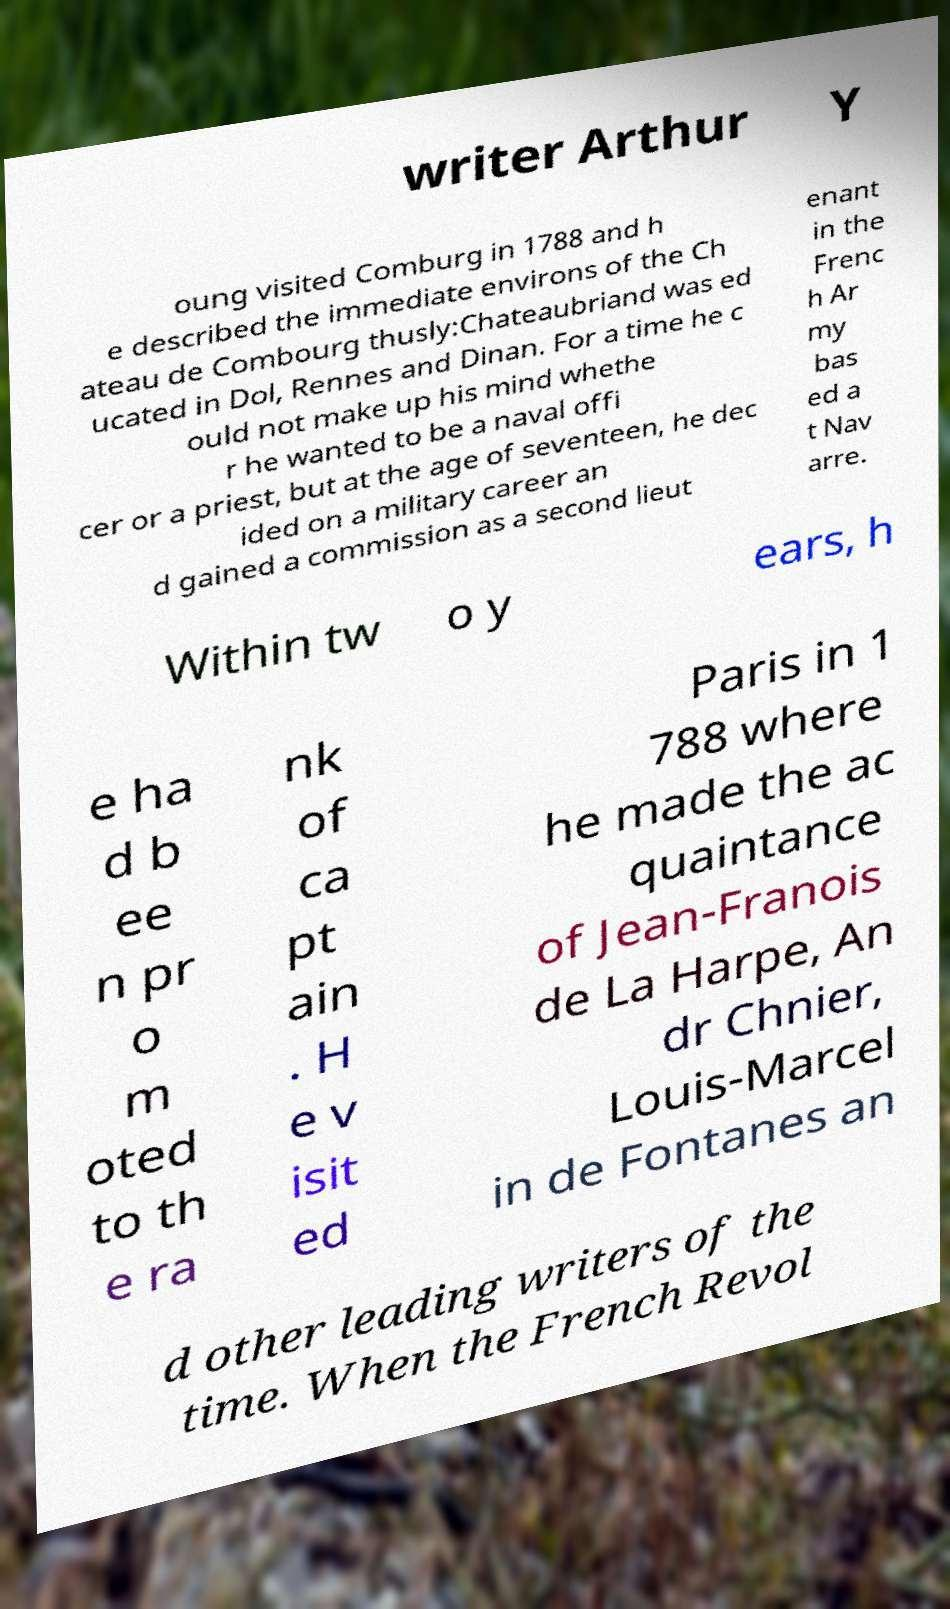What messages or text are displayed in this image? I need them in a readable, typed format. writer Arthur Y oung visited Comburg in 1788 and h e described the immediate environs of the Ch ateau de Combourg thusly:Chateaubriand was ed ucated in Dol, Rennes and Dinan. For a time he c ould not make up his mind whethe r he wanted to be a naval offi cer or a priest, but at the age of seventeen, he dec ided on a military career an d gained a commission as a second lieut enant in the Frenc h Ar my bas ed a t Nav arre. Within tw o y ears, h e ha d b ee n pr o m oted to th e ra nk of ca pt ain . H e v isit ed Paris in 1 788 where he made the ac quaintance of Jean-Franois de La Harpe, An dr Chnier, Louis-Marcel in de Fontanes an d other leading writers of the time. When the French Revol 